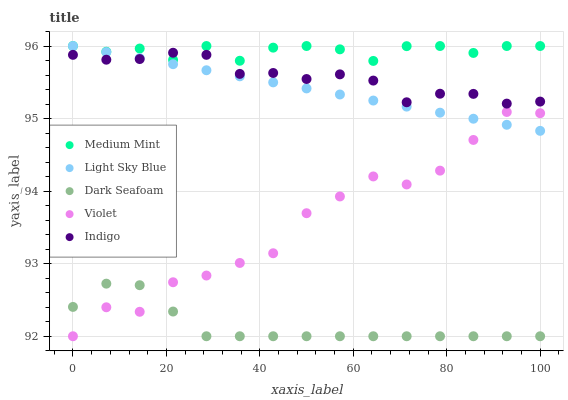Does Dark Seafoam have the minimum area under the curve?
Answer yes or no. Yes. Does Medium Mint have the maximum area under the curve?
Answer yes or no. Yes. Does Light Sky Blue have the minimum area under the curve?
Answer yes or no. No. Does Light Sky Blue have the maximum area under the curve?
Answer yes or no. No. Is Light Sky Blue the smoothest?
Answer yes or no. Yes. Is Violet the roughest?
Answer yes or no. Yes. Is Dark Seafoam the smoothest?
Answer yes or no. No. Is Dark Seafoam the roughest?
Answer yes or no. No. Does Dark Seafoam have the lowest value?
Answer yes or no. Yes. Does Light Sky Blue have the lowest value?
Answer yes or no. No. Does Light Sky Blue have the highest value?
Answer yes or no. Yes. Does Dark Seafoam have the highest value?
Answer yes or no. No. Is Violet less than Medium Mint?
Answer yes or no. Yes. Is Medium Mint greater than Violet?
Answer yes or no. Yes. Does Indigo intersect Medium Mint?
Answer yes or no. Yes. Is Indigo less than Medium Mint?
Answer yes or no. No. Is Indigo greater than Medium Mint?
Answer yes or no. No. Does Violet intersect Medium Mint?
Answer yes or no. No. 